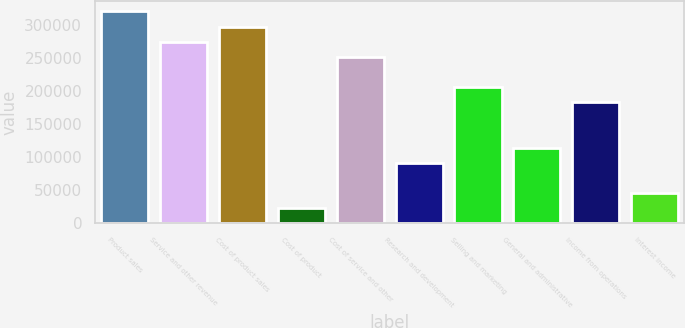Convert chart to OTSL. <chart><loc_0><loc_0><loc_500><loc_500><bar_chart><fcel>Product sales<fcel>Service and other revenue<fcel>Cost of product sales<fcel>Cost of product<fcel>Cost of service and other<fcel>Research and development<fcel>Selling and marketing<fcel>General and administrative<fcel>Income from operations<fcel>Interest income<nl><fcel>320643<fcel>274859<fcel>297751<fcel>23047<fcel>251967<fcel>91723<fcel>206183<fcel>114615<fcel>183291<fcel>45939<nl></chart> 